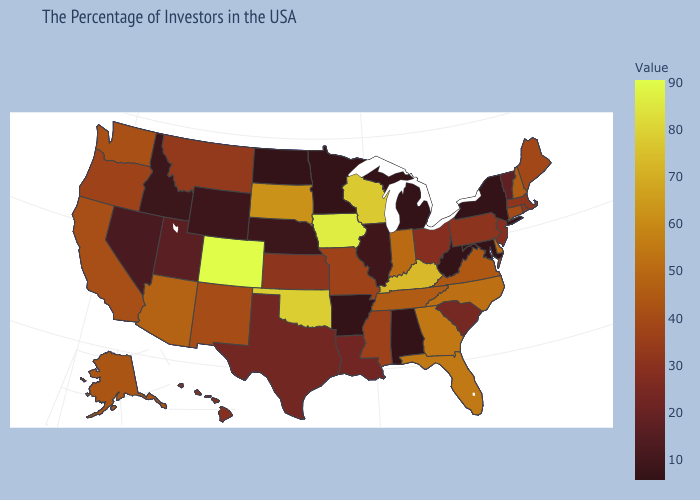Among the states that border Colorado , does Nebraska have the lowest value?
Answer briefly. Yes. Does Rhode Island have a lower value than Indiana?
Keep it brief. Yes. Which states have the lowest value in the USA?
Concise answer only. New York, Maryland, West Virginia, Michigan, Alabama, Arkansas, Minnesota, North Dakota. Does the map have missing data?
Answer briefly. No. Among the states that border Michigan , which have the lowest value?
Be succinct. Ohio. 